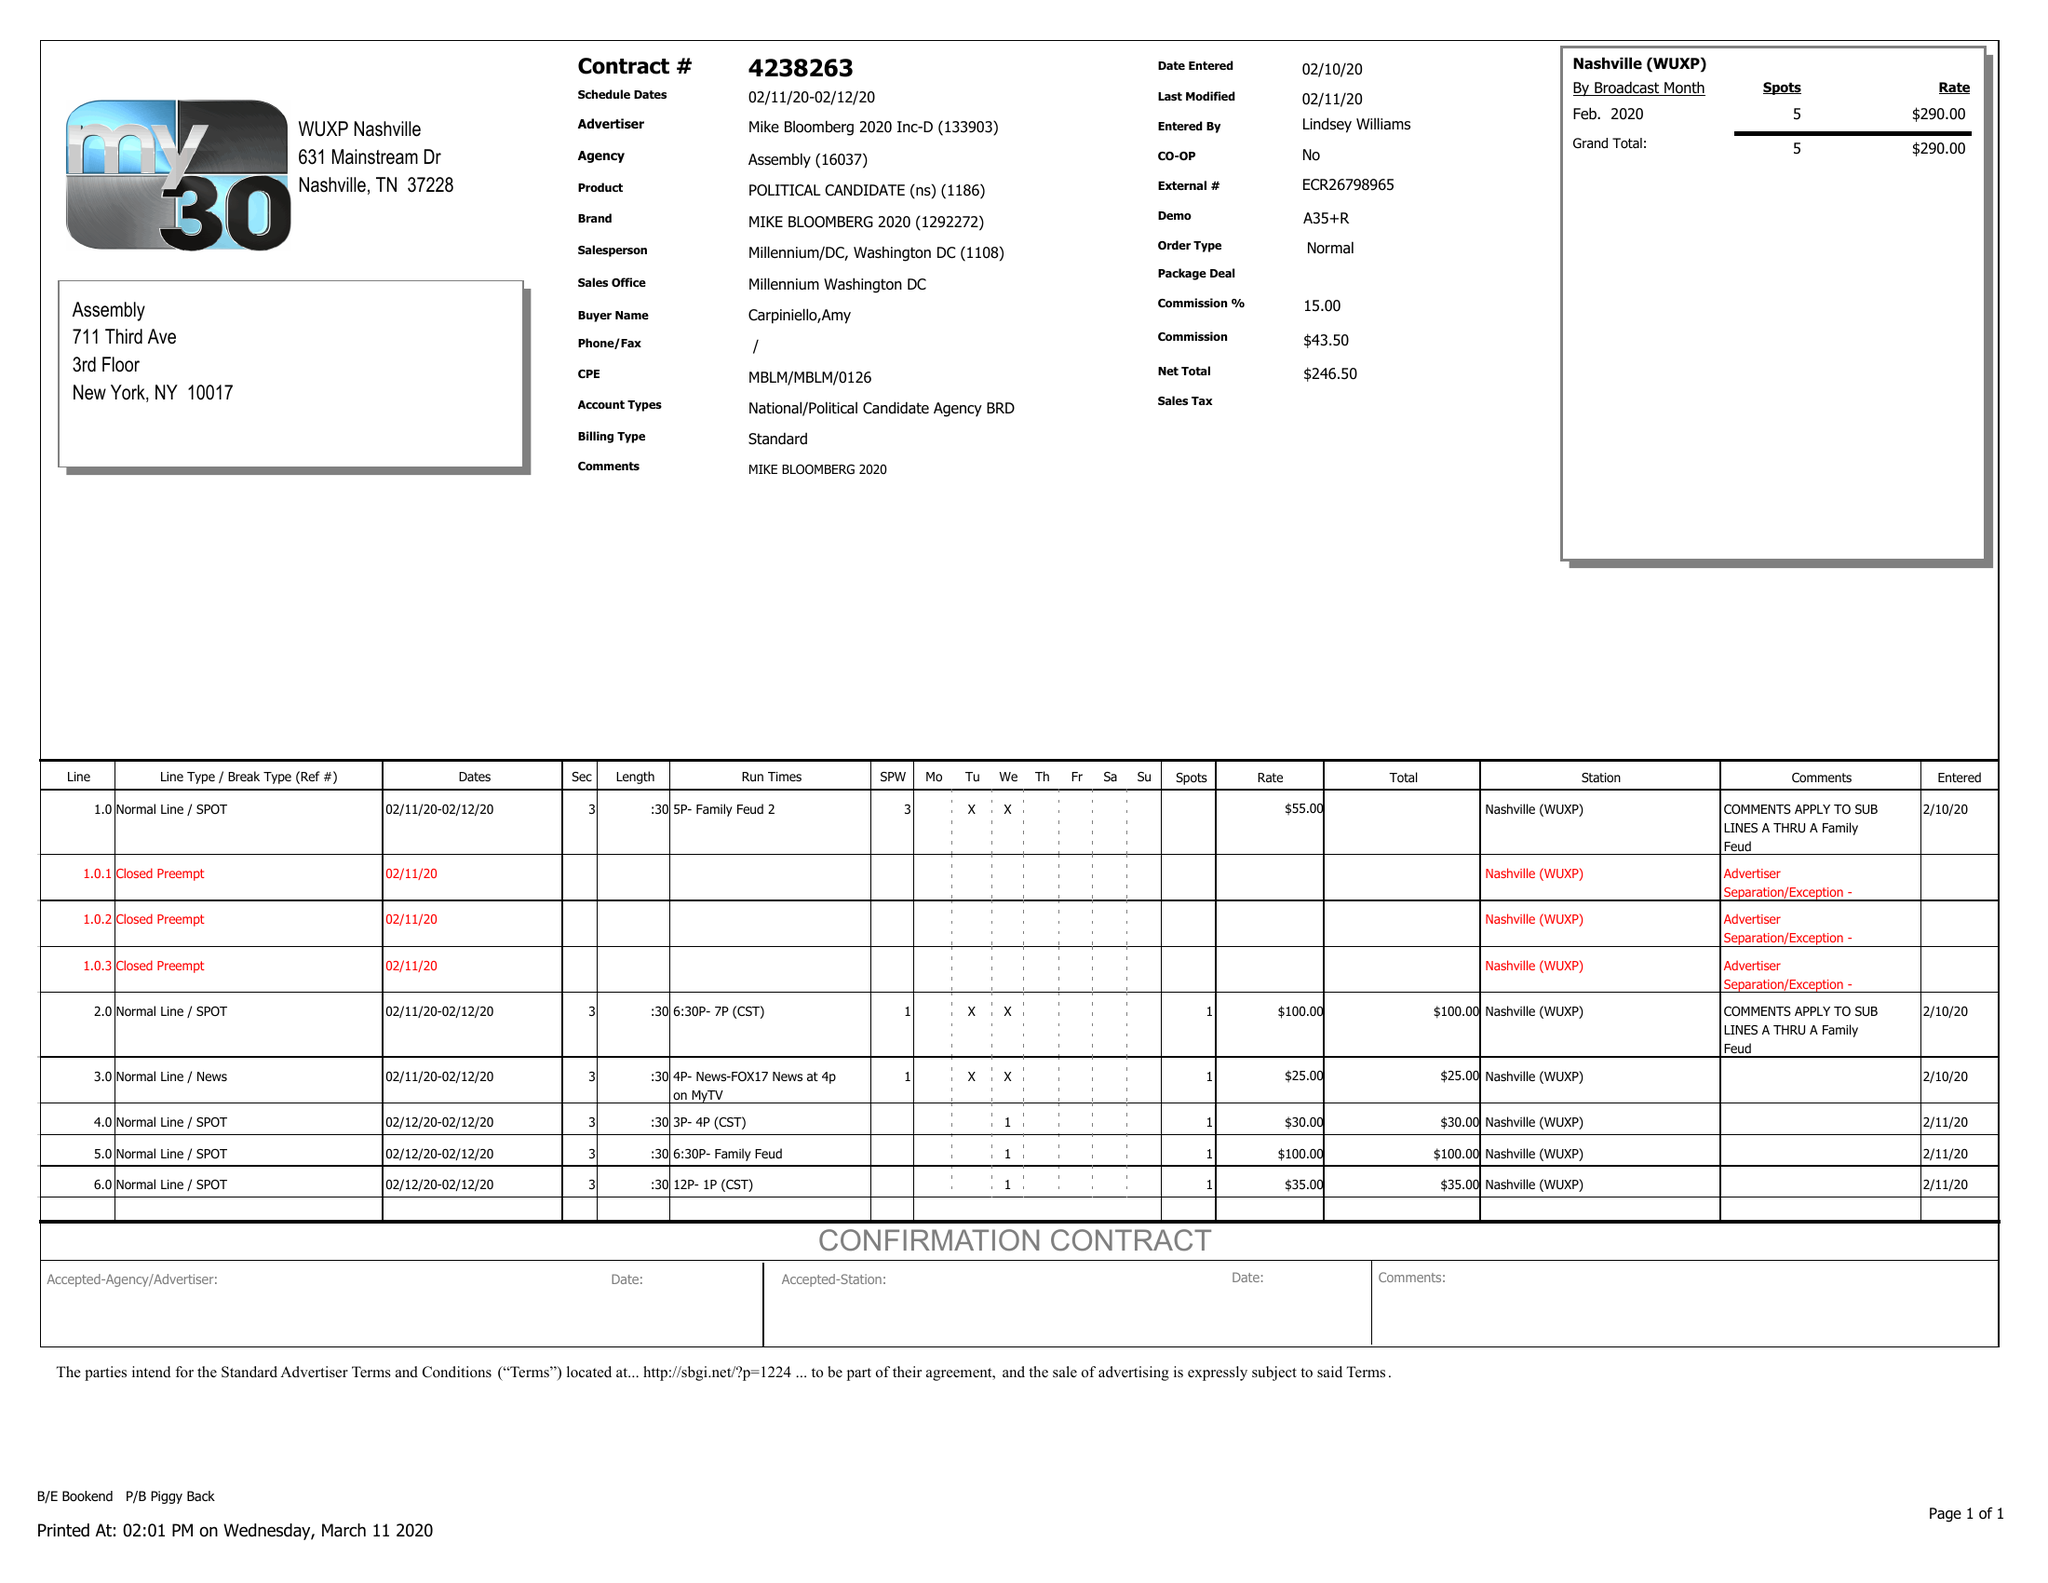What is the value for the flight_to?
Answer the question using a single word or phrase. 02/12/20 